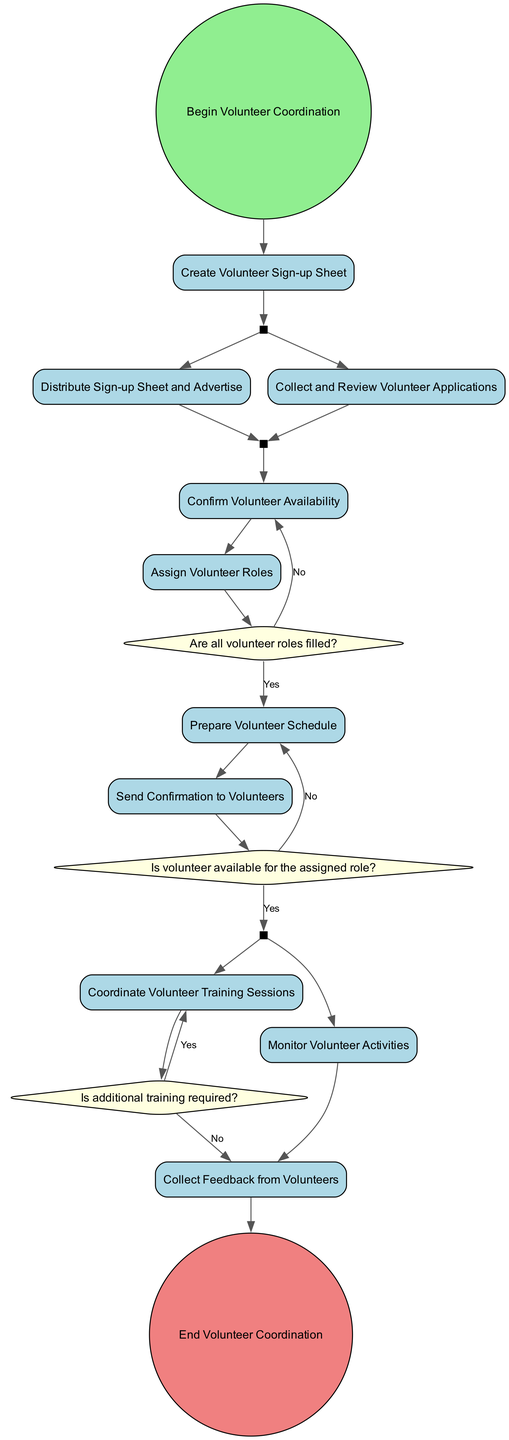What is the first activity in the diagram? The diagram starts with the event labeled "Begin Volunteer Coordination." The first activity that follows it, visually connected to this start event, is "Create Volunteer Sign-up Sheet."
Answer: Create Volunteer Sign-up Sheet How many decision points are there in the diagram? There are three decision nodes in the diagram: "Are all volunteer roles filled?", "Is volunteer available for the assigned role?", and "Is additional training required?" This can be counted by identifying diamond-shaped nodes.
Answer: 3 What happens if a volunteer is not available for the assigned role? If a volunteer is not available for the assigned role, the flow returns to the activity "Confirm Volunteer Availability," ensuring that the coordination process continues until a match is found.
Answer: Repeat Confirm Volunteer Availability Which activities are performed concurrently after distributing the sign-up sheet? After distributing the sign-up sheet, the diagram indicates that "Distribute Sign-up Sheet and Advertise" is followed by two activities happening concurrently: collecting applications and assigning roles.
Answer: Collect and Review Volunteer Applications, Assign Volunteer Roles What is the final step in the volunteer coordination process? The diagram concludes with the event labeled "End Volunteer Coordination," indicating the completion of all defined activities and checks. This node follows the last activity, which is "Collect Feedback from Volunteers."
Answer: End Volunteer Coordination What is the significance of the join node in the diagram? The join node represents a point where multiple parallel activities converge back into a single flow. In the diagram, after collecting applications, it is where "Collect and Review Volunteer Applications" and "Distribute Sign-up Sheet and Advertise" combine before continuing to the next activity.
Answer: Coordination of activities Are there any activities that require additional training? Yes, the node labeled "Is additional training required?" explicitly asks this question, and depending on its answer, the flow can lead to either conducting training or collecting feedback from volunteers.
Answer: Yes How many activities must be completed before sending confirmations to volunteers? Between the start event and sending confirmations, several activities must be completed including creating a sign-up sheet, collecting applications, confirming availability, assigning roles, and preparing a schedule, totaling five activities.
Answer: 5 Which activity follows after the decision of "Are all volunteer roles filled?" with a 'No' response? If the response to "Are all volunteer roles filled?" is 'No', the flow redirects back to the activity "Confirm Volunteer Availability," indicating that further coordination is needed to fill the roles.
Answer: Confirm Volunteer Availability 